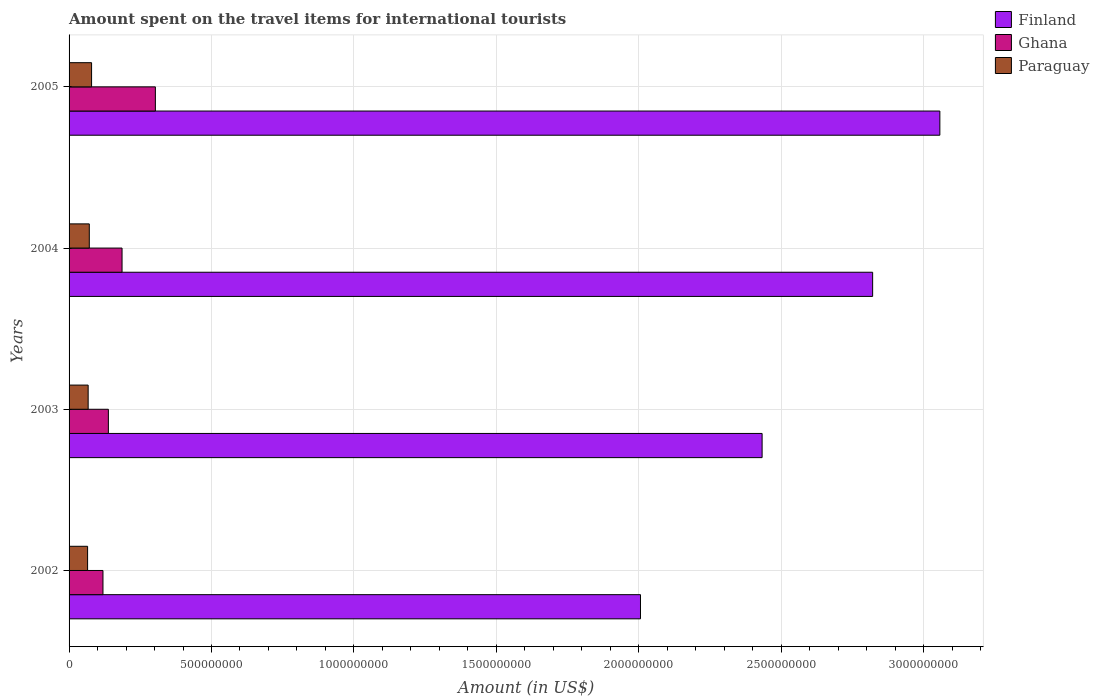How many different coloured bars are there?
Provide a short and direct response. 3. How many groups of bars are there?
Give a very brief answer. 4. Are the number of bars on each tick of the Y-axis equal?
Provide a succinct answer. Yes. How many bars are there on the 2nd tick from the top?
Make the answer very short. 3. In how many cases, is the number of bars for a given year not equal to the number of legend labels?
Your answer should be compact. 0. What is the amount spent on the travel items for international tourists in Ghana in 2005?
Your answer should be compact. 3.03e+08. Across all years, what is the maximum amount spent on the travel items for international tourists in Ghana?
Give a very brief answer. 3.03e+08. Across all years, what is the minimum amount spent on the travel items for international tourists in Ghana?
Offer a terse response. 1.19e+08. In which year was the amount spent on the travel items for international tourists in Ghana maximum?
Offer a very short reply. 2005. What is the total amount spent on the travel items for international tourists in Paraguay in the graph?
Make the answer very short. 2.82e+08. What is the difference between the amount spent on the travel items for international tourists in Ghana in 2004 and that in 2005?
Make the answer very short. -1.17e+08. What is the difference between the amount spent on the travel items for international tourists in Paraguay in 2004 and the amount spent on the travel items for international tourists in Finland in 2005?
Ensure brevity in your answer.  -2.99e+09. What is the average amount spent on the travel items for international tourists in Finland per year?
Your answer should be very brief. 2.58e+09. In the year 2004, what is the difference between the amount spent on the travel items for international tourists in Finland and amount spent on the travel items for international tourists in Ghana?
Make the answer very short. 2.64e+09. In how many years, is the amount spent on the travel items for international tourists in Paraguay greater than 300000000 US$?
Provide a short and direct response. 0. What is the ratio of the amount spent on the travel items for international tourists in Finland in 2004 to that in 2005?
Give a very brief answer. 0.92. Is the difference between the amount spent on the travel items for international tourists in Finland in 2002 and 2005 greater than the difference between the amount spent on the travel items for international tourists in Ghana in 2002 and 2005?
Keep it short and to the point. No. What is the difference between the highest and the lowest amount spent on the travel items for international tourists in Finland?
Your answer should be compact. 1.05e+09. What does the 3rd bar from the bottom in 2002 represents?
Offer a very short reply. Paraguay. Is it the case that in every year, the sum of the amount spent on the travel items for international tourists in Ghana and amount spent on the travel items for international tourists in Paraguay is greater than the amount spent on the travel items for international tourists in Finland?
Give a very brief answer. No. Are all the bars in the graph horizontal?
Your answer should be compact. Yes. Are the values on the major ticks of X-axis written in scientific E-notation?
Keep it short and to the point. No. Where does the legend appear in the graph?
Provide a short and direct response. Top right. How are the legend labels stacked?
Provide a succinct answer. Vertical. What is the title of the graph?
Ensure brevity in your answer.  Amount spent on the travel items for international tourists. What is the Amount (in US$) of Finland in 2002?
Provide a succinct answer. 2.01e+09. What is the Amount (in US$) of Ghana in 2002?
Offer a very short reply. 1.19e+08. What is the Amount (in US$) of Paraguay in 2002?
Your answer should be compact. 6.50e+07. What is the Amount (in US$) in Finland in 2003?
Keep it short and to the point. 2.43e+09. What is the Amount (in US$) of Ghana in 2003?
Provide a succinct answer. 1.38e+08. What is the Amount (in US$) of Paraguay in 2003?
Make the answer very short. 6.70e+07. What is the Amount (in US$) in Finland in 2004?
Give a very brief answer. 2.82e+09. What is the Amount (in US$) of Ghana in 2004?
Provide a succinct answer. 1.86e+08. What is the Amount (in US$) in Paraguay in 2004?
Offer a very short reply. 7.10e+07. What is the Amount (in US$) in Finland in 2005?
Offer a terse response. 3.06e+09. What is the Amount (in US$) of Ghana in 2005?
Give a very brief answer. 3.03e+08. What is the Amount (in US$) in Paraguay in 2005?
Your answer should be compact. 7.90e+07. Across all years, what is the maximum Amount (in US$) of Finland?
Ensure brevity in your answer.  3.06e+09. Across all years, what is the maximum Amount (in US$) in Ghana?
Your answer should be very brief. 3.03e+08. Across all years, what is the maximum Amount (in US$) of Paraguay?
Your response must be concise. 7.90e+07. Across all years, what is the minimum Amount (in US$) of Finland?
Make the answer very short. 2.01e+09. Across all years, what is the minimum Amount (in US$) of Ghana?
Ensure brevity in your answer.  1.19e+08. Across all years, what is the minimum Amount (in US$) of Paraguay?
Your answer should be very brief. 6.50e+07. What is the total Amount (in US$) of Finland in the graph?
Offer a terse response. 1.03e+1. What is the total Amount (in US$) in Ghana in the graph?
Provide a short and direct response. 7.46e+08. What is the total Amount (in US$) in Paraguay in the graph?
Your answer should be very brief. 2.82e+08. What is the difference between the Amount (in US$) in Finland in 2002 and that in 2003?
Offer a very short reply. -4.27e+08. What is the difference between the Amount (in US$) in Ghana in 2002 and that in 2003?
Your response must be concise. -1.90e+07. What is the difference between the Amount (in US$) of Paraguay in 2002 and that in 2003?
Provide a succinct answer. -2.00e+06. What is the difference between the Amount (in US$) in Finland in 2002 and that in 2004?
Provide a succinct answer. -8.15e+08. What is the difference between the Amount (in US$) of Ghana in 2002 and that in 2004?
Provide a succinct answer. -6.70e+07. What is the difference between the Amount (in US$) of Paraguay in 2002 and that in 2004?
Ensure brevity in your answer.  -6.00e+06. What is the difference between the Amount (in US$) in Finland in 2002 and that in 2005?
Your answer should be compact. -1.05e+09. What is the difference between the Amount (in US$) in Ghana in 2002 and that in 2005?
Ensure brevity in your answer.  -1.84e+08. What is the difference between the Amount (in US$) of Paraguay in 2002 and that in 2005?
Your response must be concise. -1.40e+07. What is the difference between the Amount (in US$) of Finland in 2003 and that in 2004?
Keep it short and to the point. -3.88e+08. What is the difference between the Amount (in US$) of Ghana in 2003 and that in 2004?
Your response must be concise. -4.80e+07. What is the difference between the Amount (in US$) of Finland in 2003 and that in 2005?
Offer a very short reply. -6.24e+08. What is the difference between the Amount (in US$) in Ghana in 2003 and that in 2005?
Provide a succinct answer. -1.65e+08. What is the difference between the Amount (in US$) of Paraguay in 2003 and that in 2005?
Ensure brevity in your answer.  -1.20e+07. What is the difference between the Amount (in US$) in Finland in 2004 and that in 2005?
Offer a very short reply. -2.36e+08. What is the difference between the Amount (in US$) in Ghana in 2004 and that in 2005?
Your response must be concise. -1.17e+08. What is the difference between the Amount (in US$) in Paraguay in 2004 and that in 2005?
Your answer should be compact. -8.00e+06. What is the difference between the Amount (in US$) of Finland in 2002 and the Amount (in US$) of Ghana in 2003?
Your answer should be compact. 1.87e+09. What is the difference between the Amount (in US$) of Finland in 2002 and the Amount (in US$) of Paraguay in 2003?
Your answer should be very brief. 1.94e+09. What is the difference between the Amount (in US$) of Ghana in 2002 and the Amount (in US$) of Paraguay in 2003?
Offer a terse response. 5.20e+07. What is the difference between the Amount (in US$) in Finland in 2002 and the Amount (in US$) in Ghana in 2004?
Provide a short and direct response. 1.82e+09. What is the difference between the Amount (in US$) of Finland in 2002 and the Amount (in US$) of Paraguay in 2004?
Provide a succinct answer. 1.94e+09. What is the difference between the Amount (in US$) of Ghana in 2002 and the Amount (in US$) of Paraguay in 2004?
Your answer should be very brief. 4.80e+07. What is the difference between the Amount (in US$) in Finland in 2002 and the Amount (in US$) in Ghana in 2005?
Your answer should be very brief. 1.70e+09. What is the difference between the Amount (in US$) in Finland in 2002 and the Amount (in US$) in Paraguay in 2005?
Offer a terse response. 1.93e+09. What is the difference between the Amount (in US$) in Ghana in 2002 and the Amount (in US$) in Paraguay in 2005?
Make the answer very short. 4.00e+07. What is the difference between the Amount (in US$) in Finland in 2003 and the Amount (in US$) in Ghana in 2004?
Offer a very short reply. 2.25e+09. What is the difference between the Amount (in US$) in Finland in 2003 and the Amount (in US$) in Paraguay in 2004?
Ensure brevity in your answer.  2.36e+09. What is the difference between the Amount (in US$) of Ghana in 2003 and the Amount (in US$) of Paraguay in 2004?
Your answer should be compact. 6.70e+07. What is the difference between the Amount (in US$) in Finland in 2003 and the Amount (in US$) in Ghana in 2005?
Your answer should be compact. 2.13e+09. What is the difference between the Amount (in US$) of Finland in 2003 and the Amount (in US$) of Paraguay in 2005?
Ensure brevity in your answer.  2.35e+09. What is the difference between the Amount (in US$) in Ghana in 2003 and the Amount (in US$) in Paraguay in 2005?
Your answer should be very brief. 5.90e+07. What is the difference between the Amount (in US$) in Finland in 2004 and the Amount (in US$) in Ghana in 2005?
Provide a short and direct response. 2.52e+09. What is the difference between the Amount (in US$) in Finland in 2004 and the Amount (in US$) in Paraguay in 2005?
Ensure brevity in your answer.  2.74e+09. What is the difference between the Amount (in US$) of Ghana in 2004 and the Amount (in US$) of Paraguay in 2005?
Provide a succinct answer. 1.07e+08. What is the average Amount (in US$) of Finland per year?
Ensure brevity in your answer.  2.58e+09. What is the average Amount (in US$) of Ghana per year?
Your response must be concise. 1.86e+08. What is the average Amount (in US$) in Paraguay per year?
Give a very brief answer. 7.05e+07. In the year 2002, what is the difference between the Amount (in US$) of Finland and Amount (in US$) of Ghana?
Provide a succinct answer. 1.89e+09. In the year 2002, what is the difference between the Amount (in US$) in Finland and Amount (in US$) in Paraguay?
Keep it short and to the point. 1.94e+09. In the year 2002, what is the difference between the Amount (in US$) of Ghana and Amount (in US$) of Paraguay?
Provide a short and direct response. 5.40e+07. In the year 2003, what is the difference between the Amount (in US$) of Finland and Amount (in US$) of Ghana?
Provide a short and direct response. 2.30e+09. In the year 2003, what is the difference between the Amount (in US$) in Finland and Amount (in US$) in Paraguay?
Make the answer very short. 2.37e+09. In the year 2003, what is the difference between the Amount (in US$) of Ghana and Amount (in US$) of Paraguay?
Your answer should be very brief. 7.10e+07. In the year 2004, what is the difference between the Amount (in US$) in Finland and Amount (in US$) in Ghana?
Your answer should be compact. 2.64e+09. In the year 2004, what is the difference between the Amount (in US$) in Finland and Amount (in US$) in Paraguay?
Offer a very short reply. 2.75e+09. In the year 2004, what is the difference between the Amount (in US$) of Ghana and Amount (in US$) of Paraguay?
Provide a succinct answer. 1.15e+08. In the year 2005, what is the difference between the Amount (in US$) in Finland and Amount (in US$) in Ghana?
Your answer should be compact. 2.75e+09. In the year 2005, what is the difference between the Amount (in US$) of Finland and Amount (in US$) of Paraguay?
Offer a terse response. 2.98e+09. In the year 2005, what is the difference between the Amount (in US$) of Ghana and Amount (in US$) of Paraguay?
Your answer should be very brief. 2.24e+08. What is the ratio of the Amount (in US$) of Finland in 2002 to that in 2003?
Your response must be concise. 0.82. What is the ratio of the Amount (in US$) in Ghana in 2002 to that in 2003?
Offer a terse response. 0.86. What is the ratio of the Amount (in US$) of Paraguay in 2002 to that in 2003?
Give a very brief answer. 0.97. What is the ratio of the Amount (in US$) of Finland in 2002 to that in 2004?
Your answer should be compact. 0.71. What is the ratio of the Amount (in US$) in Ghana in 2002 to that in 2004?
Offer a very short reply. 0.64. What is the ratio of the Amount (in US$) of Paraguay in 2002 to that in 2004?
Provide a succinct answer. 0.92. What is the ratio of the Amount (in US$) of Finland in 2002 to that in 2005?
Give a very brief answer. 0.66. What is the ratio of the Amount (in US$) in Ghana in 2002 to that in 2005?
Offer a very short reply. 0.39. What is the ratio of the Amount (in US$) in Paraguay in 2002 to that in 2005?
Give a very brief answer. 0.82. What is the ratio of the Amount (in US$) in Finland in 2003 to that in 2004?
Your response must be concise. 0.86. What is the ratio of the Amount (in US$) of Ghana in 2003 to that in 2004?
Your answer should be very brief. 0.74. What is the ratio of the Amount (in US$) of Paraguay in 2003 to that in 2004?
Your response must be concise. 0.94. What is the ratio of the Amount (in US$) of Finland in 2003 to that in 2005?
Your response must be concise. 0.8. What is the ratio of the Amount (in US$) in Ghana in 2003 to that in 2005?
Provide a succinct answer. 0.46. What is the ratio of the Amount (in US$) of Paraguay in 2003 to that in 2005?
Your answer should be compact. 0.85. What is the ratio of the Amount (in US$) of Finland in 2004 to that in 2005?
Ensure brevity in your answer.  0.92. What is the ratio of the Amount (in US$) in Ghana in 2004 to that in 2005?
Keep it short and to the point. 0.61. What is the ratio of the Amount (in US$) in Paraguay in 2004 to that in 2005?
Your response must be concise. 0.9. What is the difference between the highest and the second highest Amount (in US$) of Finland?
Provide a succinct answer. 2.36e+08. What is the difference between the highest and the second highest Amount (in US$) of Ghana?
Your response must be concise. 1.17e+08. What is the difference between the highest and the lowest Amount (in US$) in Finland?
Provide a short and direct response. 1.05e+09. What is the difference between the highest and the lowest Amount (in US$) in Ghana?
Provide a short and direct response. 1.84e+08. What is the difference between the highest and the lowest Amount (in US$) of Paraguay?
Ensure brevity in your answer.  1.40e+07. 